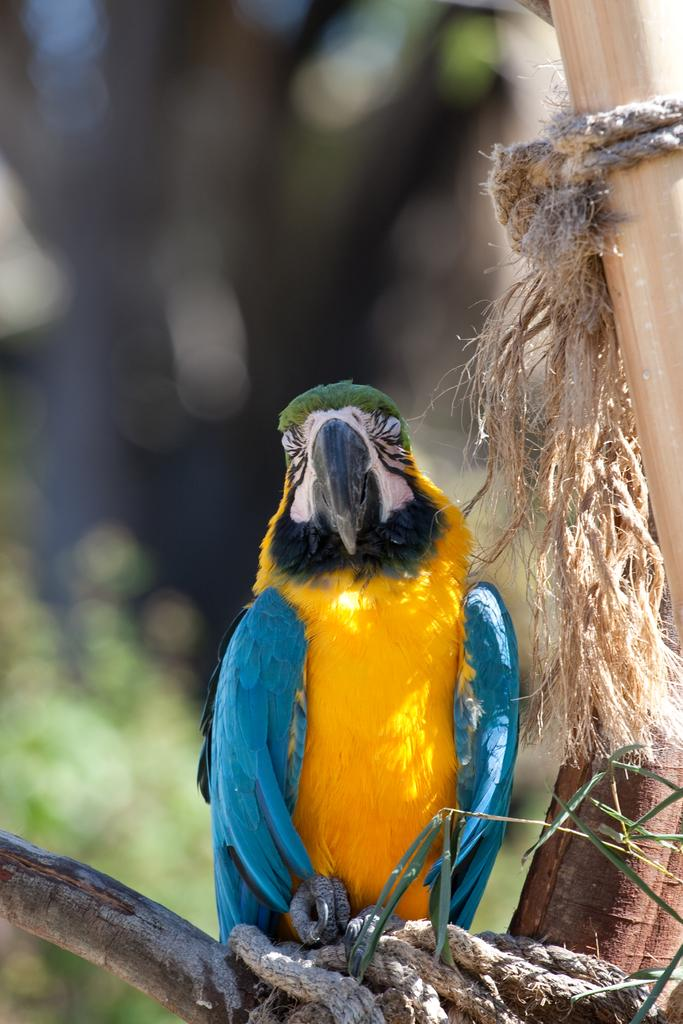What type of animal can be seen in the image? There is a bird in the image. Where is the bird located in the image? The bird is sitting on a tree. What type of pest is visible in the image? There is no pest visible in the image; it features a bird sitting on a tree. 